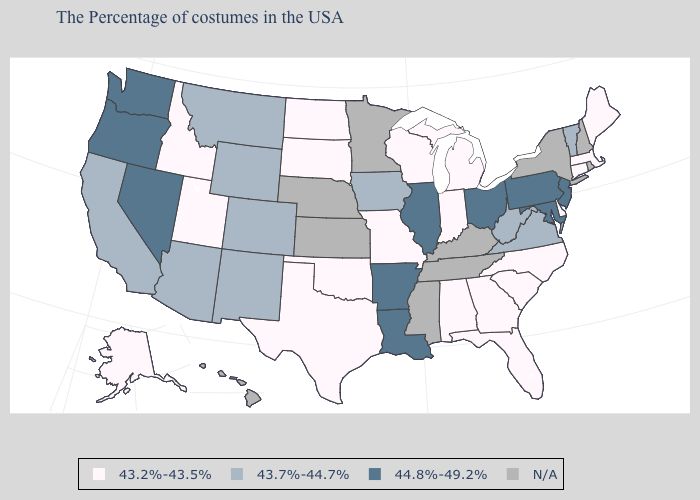What is the lowest value in the South?
Be succinct. 43.2%-43.5%. Name the states that have a value in the range 43.2%-43.5%?
Quick response, please. Maine, Massachusetts, Connecticut, Delaware, North Carolina, South Carolina, Florida, Georgia, Michigan, Indiana, Alabama, Wisconsin, Missouri, Oklahoma, Texas, South Dakota, North Dakota, Utah, Idaho, Alaska. Is the legend a continuous bar?
Give a very brief answer. No. Does Montana have the highest value in the USA?
Keep it brief. No. Among the states that border North Dakota , which have the lowest value?
Answer briefly. South Dakota. Which states have the lowest value in the Northeast?
Short answer required. Maine, Massachusetts, Connecticut. Does North Dakota have the lowest value in the MidWest?
Write a very short answer. Yes. What is the value of Arizona?
Short answer required. 43.7%-44.7%. Does Montana have the lowest value in the USA?
Short answer required. No. Does South Carolina have the lowest value in the USA?
Answer briefly. Yes. Is the legend a continuous bar?
Quick response, please. No. Does the first symbol in the legend represent the smallest category?
Keep it brief. Yes. 